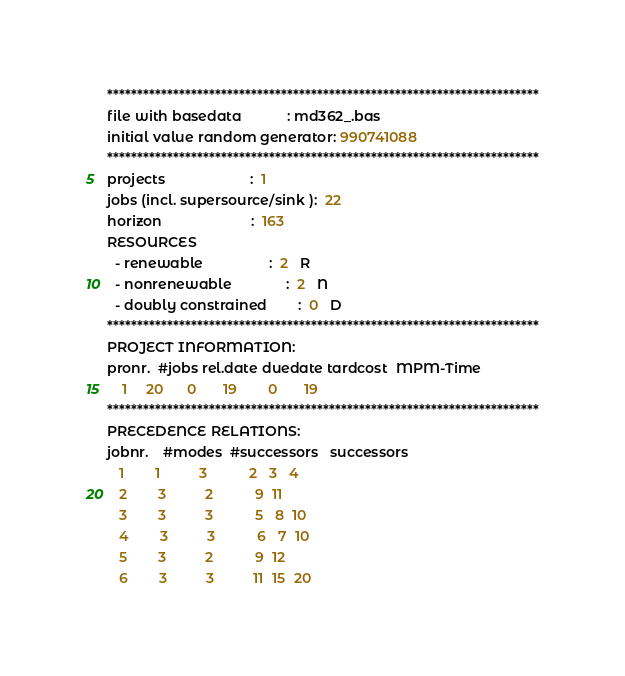Convert code to text. <code><loc_0><loc_0><loc_500><loc_500><_ObjectiveC_>************************************************************************
file with basedata            : md362_.bas
initial value random generator: 990741088
************************************************************************
projects                      :  1
jobs (incl. supersource/sink ):  22
horizon                       :  163
RESOURCES
  - renewable                 :  2   R
  - nonrenewable              :  2   N
  - doubly constrained        :  0   D
************************************************************************
PROJECT INFORMATION:
pronr.  #jobs rel.date duedate tardcost  MPM-Time
    1     20      0       19        0       19
************************************************************************
PRECEDENCE RELATIONS:
jobnr.    #modes  #successors   successors
   1        1          3           2   3   4
   2        3          2           9  11
   3        3          3           5   8  10
   4        3          3           6   7  10
   5        3          2           9  12
   6        3          3          11  15  20</code> 